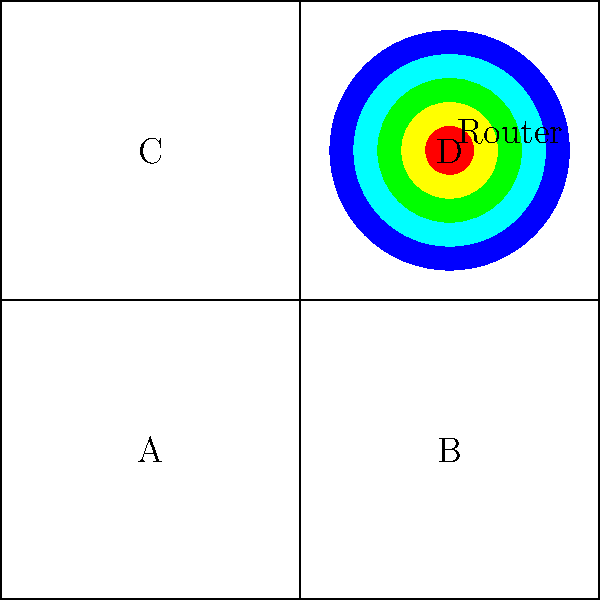Based on the Wi-Fi signal strength heatmap shown in the office layout, which area is likely to have the weakest Wi-Fi signal? To determine the area with the weakest Wi-Fi signal, we need to analyze the heatmap and understand how Wi-Fi signal strength is typically represented:

1. The heatmap uses colors to represent signal strength, with red typically indicating the strongest signal and blue the weakest.

2. The Wi-Fi router is located in the top-right quadrant (area D), as indicated by the red dot.

3. The concentric circles surrounding the router show how the signal strength decreases as we move away from the router.

4. The color gradient moves from red (strongest) near the router to blue (weakest) at the furthest points.

5. Looking at the four quadrants (A, B, C, D):
   - Area D has the router and is mostly red, indicating the strongest signal.
   - Areas B and C are closer to the router and have a mix of yellow and green, indicating moderate signal strength.
   - Area A is the furthest from the router and is mostly blue, indicating the weakest signal.

6. The signal strength is weakest in the bottom-left corner of area A, as it's the point furthest from the router and is represented by the darkest blue color.

Therefore, based on the heatmap, area A (bottom-left quadrant) is likely to have the weakest Wi-Fi signal.
Answer: Area A (bottom-left quadrant) 